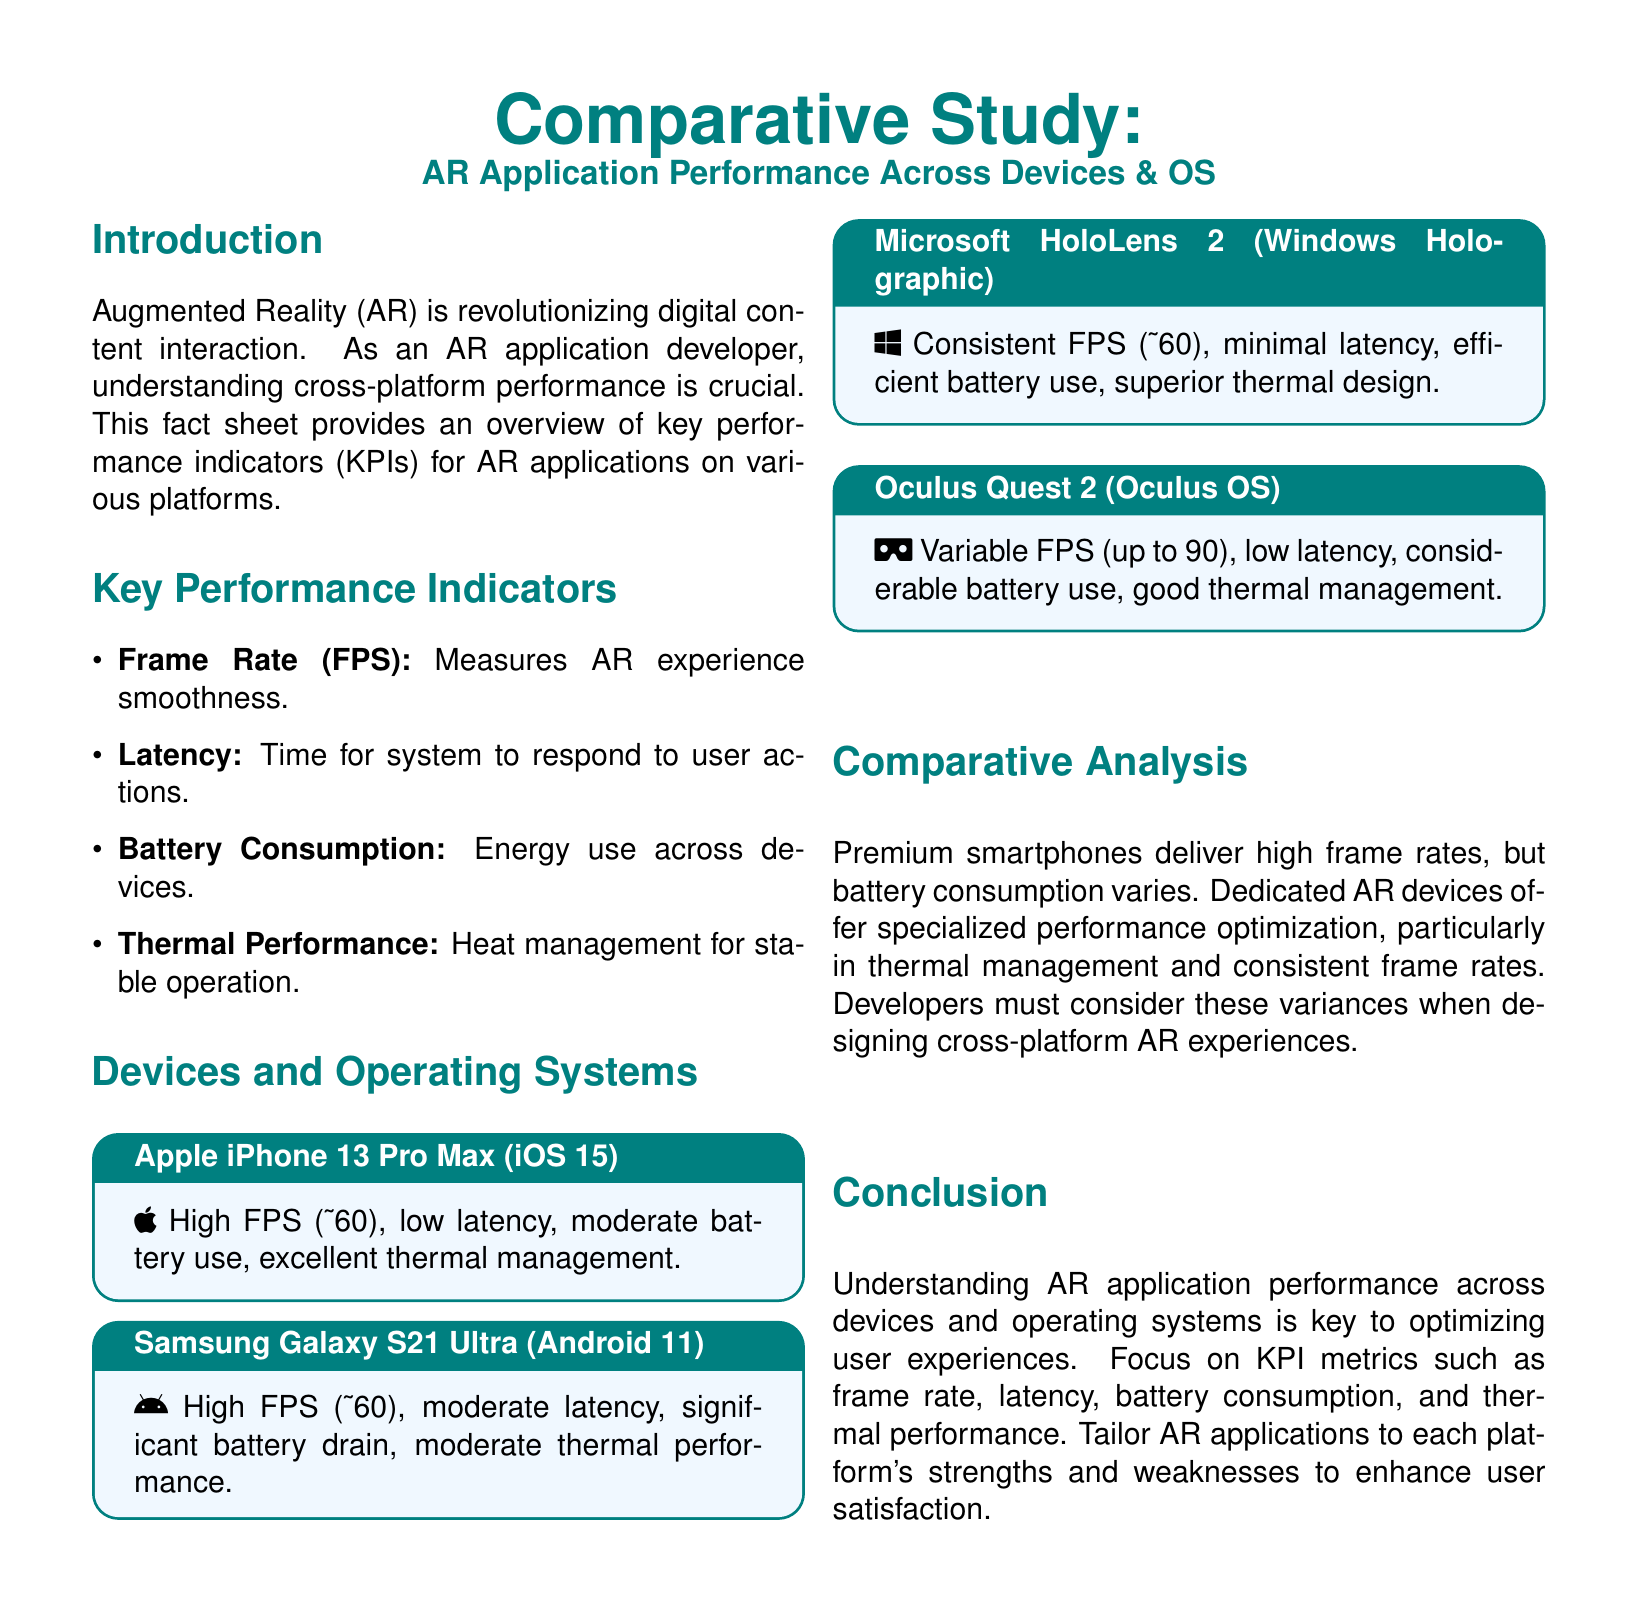What is the frame rate for Apple iPhone 13 Pro Max? The frame rate for Apple iPhone 13 Pro Max is approximately 60 FPS.
Answer: approximately 60 FPS What is the battery consumption characteristic of the Samsung Galaxy S21 Ultra? The battery consumption for Samsung Galaxy S21 Ultra is significant.
Answer: significant How does the thermal performance of Microsoft HoloLens 2 compare to other devices? The thermal performance of Microsoft HoloLens 2 is superior.
Answer: superior What is the frame rate variability for Oculus Quest 2? The frame rate for Oculus Quest 2 can go up to 90 FPS.
Answer: up to 90 FPS Which operating system is associated with Samsung Galaxy S21 Ultra? The operating system associated with Samsung Galaxy S21 Ultra is Android 11.
Answer: Android 11 What key performance indicator is used to measure AR experience smoothness? The key performance indicator used to measure AR experience smoothness is Frame Rate (FPS).
Answer: Frame Rate (FPS) Which special feature does dedicated AR devices excel in? Dedicated AR devices excel in thermal management.
Answer: thermal management What type of document is this? This document is a fact sheet.
Answer: fact sheet How many devices are analyzed in this study? Four devices are analyzed in the study.
Answer: four 